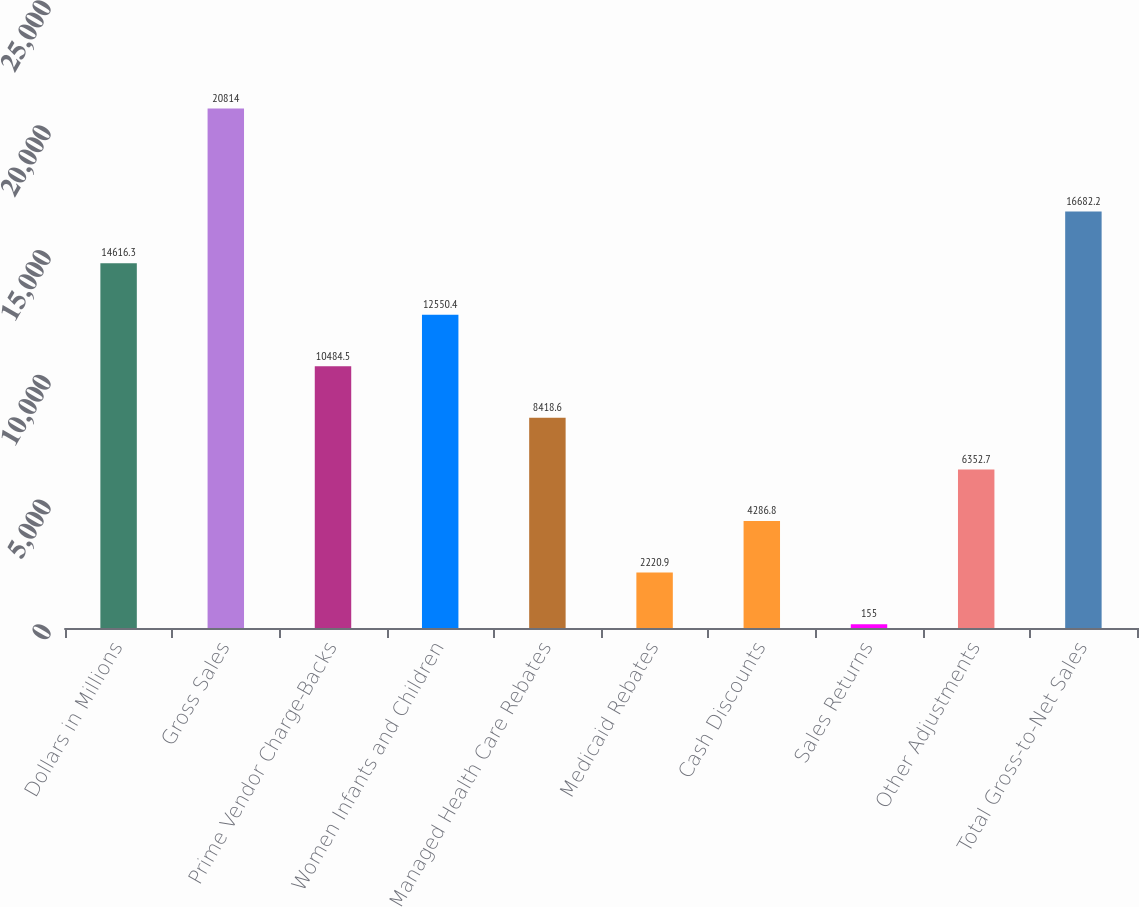Convert chart to OTSL. <chart><loc_0><loc_0><loc_500><loc_500><bar_chart><fcel>Dollars in Millions<fcel>Gross Sales<fcel>Prime Vendor Charge-Backs<fcel>Women Infants and Children<fcel>Managed Health Care Rebates<fcel>Medicaid Rebates<fcel>Cash Discounts<fcel>Sales Returns<fcel>Other Adjustments<fcel>Total Gross-to-Net Sales<nl><fcel>14616.3<fcel>20814<fcel>10484.5<fcel>12550.4<fcel>8418.6<fcel>2220.9<fcel>4286.8<fcel>155<fcel>6352.7<fcel>16682.2<nl></chart> 